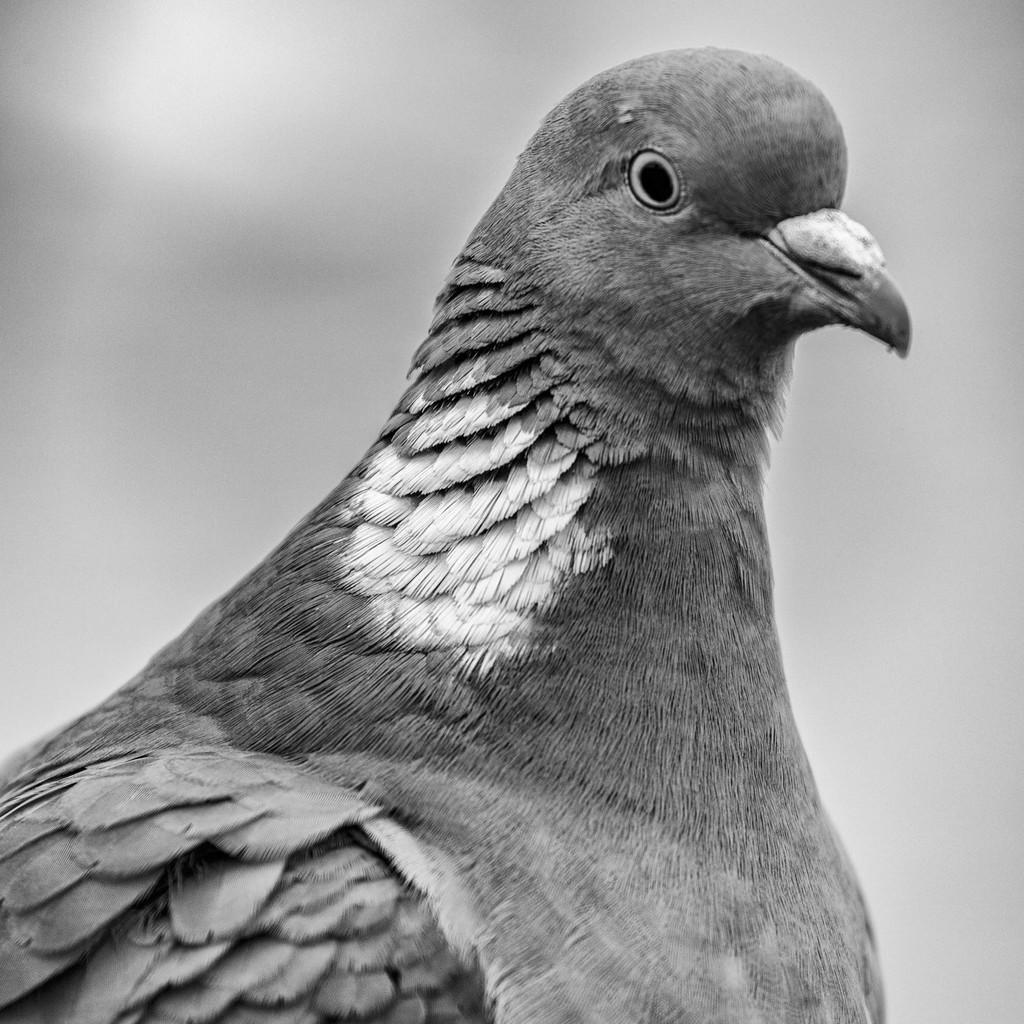What type of bird is in the picture? There is a pigeon in the picture. Can you describe the color of the pigeon's feathers? The pigeon has white and grey feathers. What can be seen in the background of the image? The backdrop of the image is blurred. Where can the sack of potatoes be found in the image? There is no sack of potatoes present in the image. What type of bushes are growing near the pigeon in the image? There are no bushes visible in the image; the backdrop is blurred. 